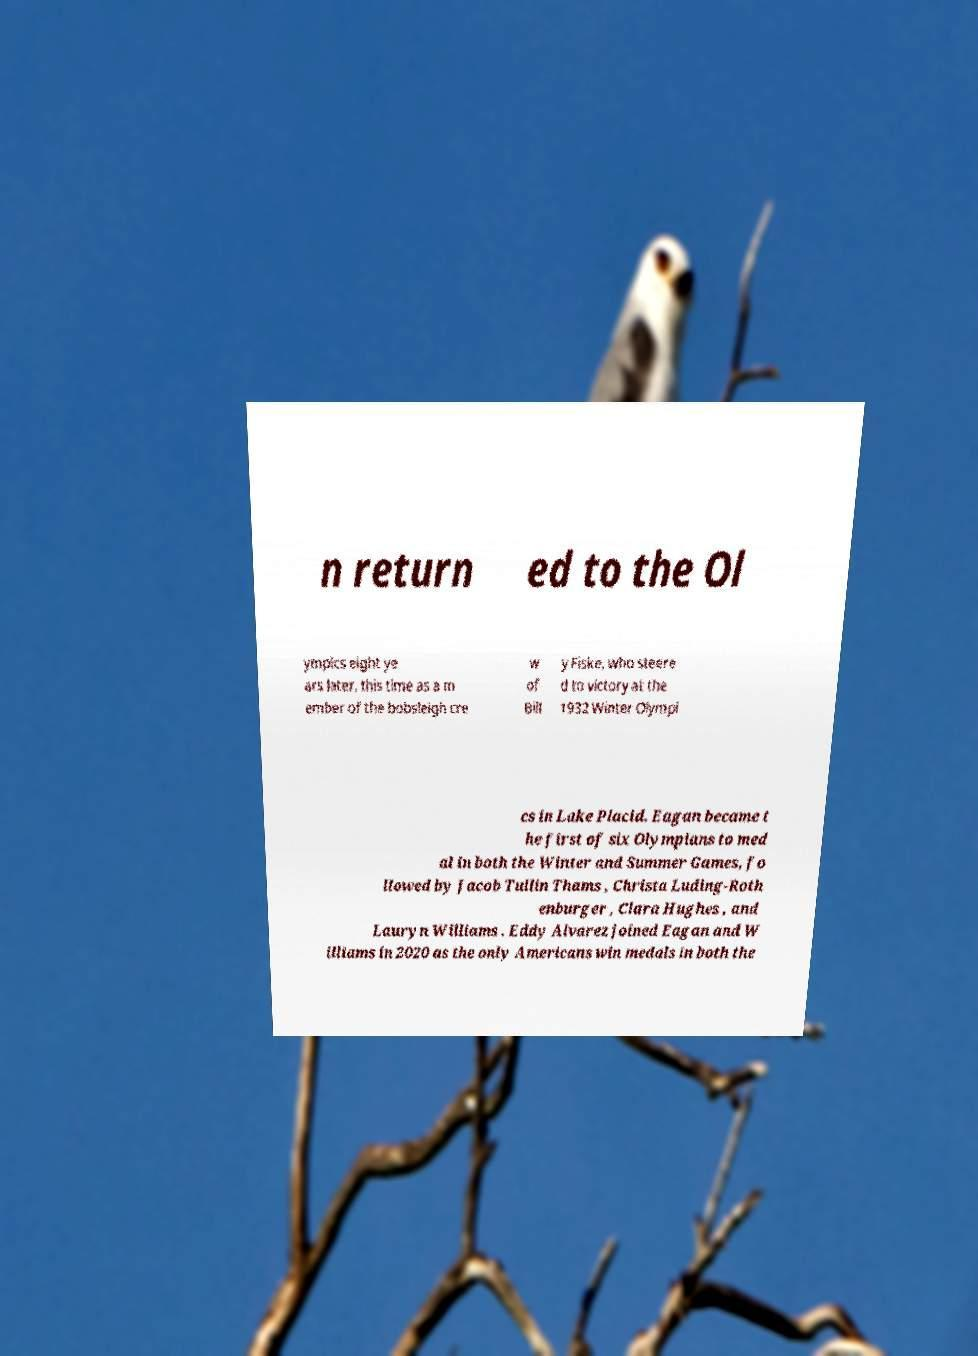Please identify and transcribe the text found in this image. n return ed to the Ol ympics eight ye ars later, this time as a m ember of the bobsleigh cre w of Bill y Fiske, who steere d to victory at the 1932 Winter Olympi cs in Lake Placid. Eagan became t he first of six Olympians to med al in both the Winter and Summer Games, fo llowed by Jacob Tullin Thams , Christa Luding-Roth enburger , Clara Hughes , and Lauryn Williams . Eddy Alvarez joined Eagan and W illiams in 2020 as the only Americans win medals in both the 